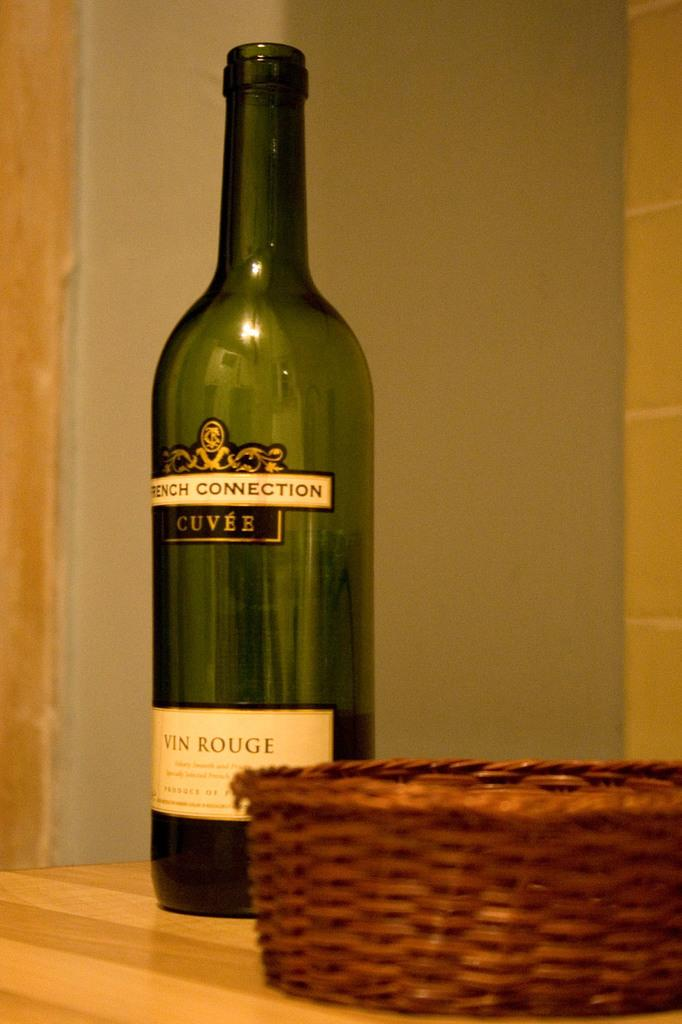Provide a one-sentence caption for the provided image. A bottle of wine is labeled FRENCH CONNECTION CUVEE. 